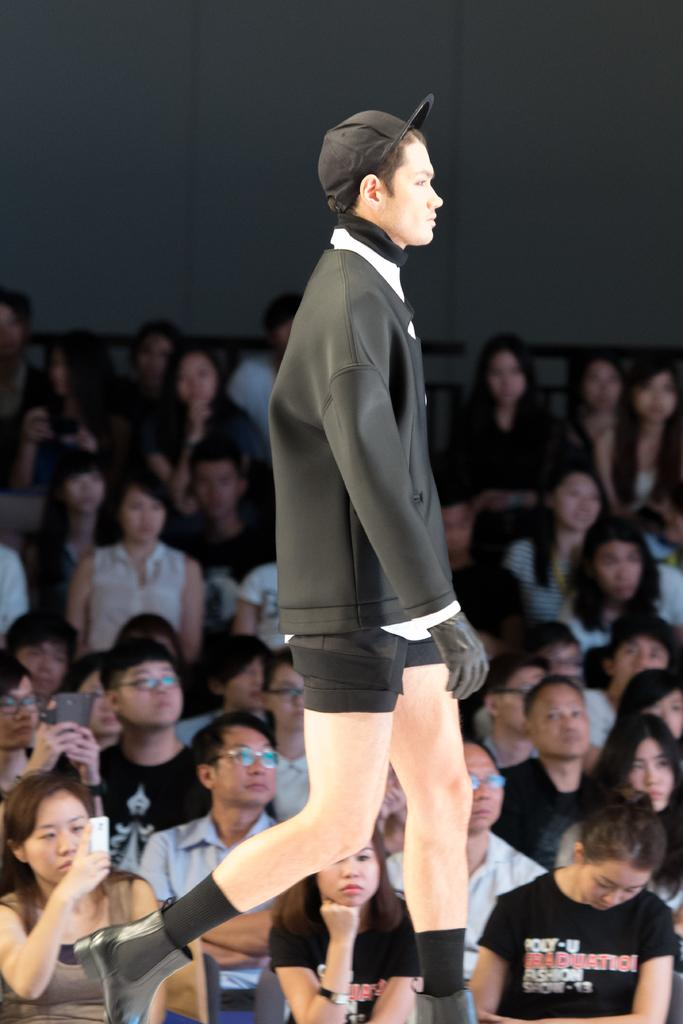What is the main subject of the image? There is a man in the image. What is the man wearing? The man is wearing a black jacket. What is the man doing in the image? The man is walking on the stage. In which direction is the man walking? The man is walking towards the right side. What can be observed about the people in the background? There are many people in the background of the image, and they are sitting and looking at the man. What type of tent can be seen in the background of the image? There is no tent present in the image. Can you describe the mountain range visible in the background? There is no mountain range visible in the background of the image. 